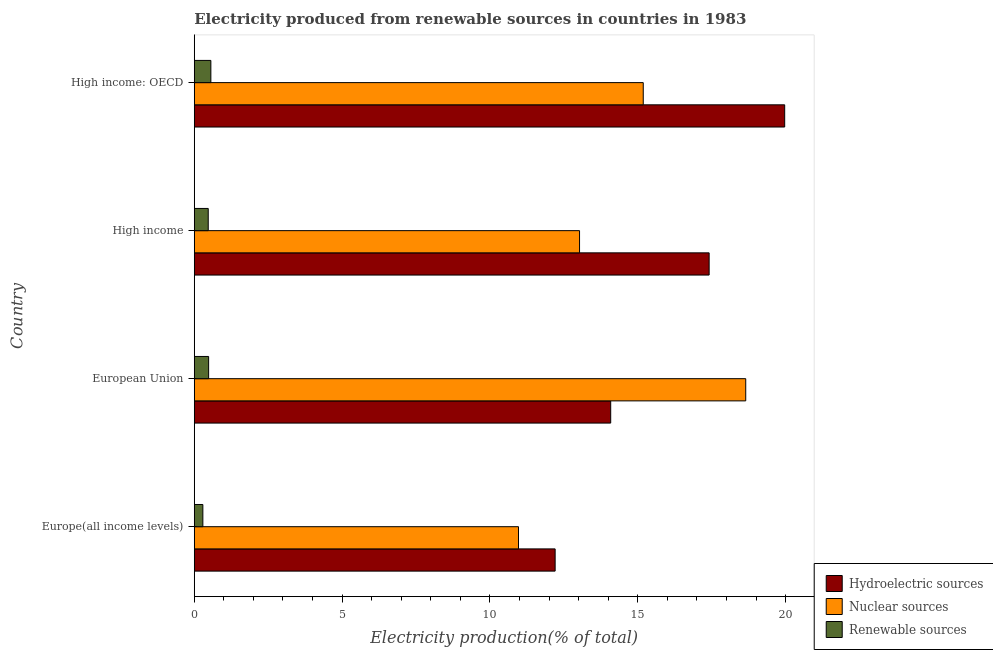How many groups of bars are there?
Ensure brevity in your answer.  4. Are the number of bars per tick equal to the number of legend labels?
Ensure brevity in your answer.  Yes. How many bars are there on the 3rd tick from the top?
Give a very brief answer. 3. What is the label of the 2nd group of bars from the top?
Your response must be concise. High income. In how many cases, is the number of bars for a given country not equal to the number of legend labels?
Offer a very short reply. 0. What is the percentage of electricity produced by renewable sources in High income?
Your answer should be very brief. 0.47. Across all countries, what is the maximum percentage of electricity produced by nuclear sources?
Offer a very short reply. 18.65. Across all countries, what is the minimum percentage of electricity produced by nuclear sources?
Provide a short and direct response. 10.97. In which country was the percentage of electricity produced by hydroelectric sources maximum?
Your response must be concise. High income: OECD. In which country was the percentage of electricity produced by renewable sources minimum?
Your response must be concise. Europe(all income levels). What is the total percentage of electricity produced by hydroelectric sources in the graph?
Offer a terse response. 63.68. What is the difference between the percentage of electricity produced by nuclear sources in High income and that in High income: OECD?
Your answer should be compact. -2.15. What is the difference between the percentage of electricity produced by nuclear sources in High income and the percentage of electricity produced by renewable sources in High income: OECD?
Give a very brief answer. 12.47. What is the average percentage of electricity produced by nuclear sources per country?
Your answer should be very brief. 14.46. What is the difference between the percentage of electricity produced by renewable sources and percentage of electricity produced by nuclear sources in High income?
Give a very brief answer. -12.56. In how many countries, is the percentage of electricity produced by nuclear sources greater than 9 %?
Give a very brief answer. 4. What is the ratio of the percentage of electricity produced by renewable sources in Europe(all income levels) to that in European Union?
Give a very brief answer. 0.6. Is the difference between the percentage of electricity produced by hydroelectric sources in European Union and High income greater than the difference between the percentage of electricity produced by nuclear sources in European Union and High income?
Your response must be concise. No. What is the difference between the highest and the second highest percentage of electricity produced by renewable sources?
Make the answer very short. 0.07. What is the difference between the highest and the lowest percentage of electricity produced by hydroelectric sources?
Provide a succinct answer. 7.76. Is the sum of the percentage of electricity produced by hydroelectric sources in Europe(all income levels) and European Union greater than the maximum percentage of electricity produced by nuclear sources across all countries?
Ensure brevity in your answer.  Yes. What does the 1st bar from the top in High income represents?
Your answer should be very brief. Renewable sources. What does the 3rd bar from the bottom in Europe(all income levels) represents?
Provide a short and direct response. Renewable sources. Is it the case that in every country, the sum of the percentage of electricity produced by hydroelectric sources and percentage of electricity produced by nuclear sources is greater than the percentage of electricity produced by renewable sources?
Make the answer very short. Yes. How many bars are there?
Your answer should be compact. 12. Are the values on the major ticks of X-axis written in scientific E-notation?
Offer a very short reply. No. Does the graph contain any zero values?
Provide a succinct answer. No. How many legend labels are there?
Provide a short and direct response. 3. What is the title of the graph?
Provide a succinct answer. Electricity produced from renewable sources in countries in 1983. Does "Grants" appear as one of the legend labels in the graph?
Give a very brief answer. No. What is the label or title of the Y-axis?
Ensure brevity in your answer.  Country. What is the Electricity production(% of total) in Hydroelectric sources in Europe(all income levels)?
Give a very brief answer. 12.21. What is the Electricity production(% of total) in Nuclear sources in Europe(all income levels)?
Provide a succinct answer. 10.97. What is the Electricity production(% of total) in Renewable sources in Europe(all income levels)?
Offer a very short reply. 0.29. What is the Electricity production(% of total) of Hydroelectric sources in European Union?
Your response must be concise. 14.09. What is the Electricity production(% of total) in Nuclear sources in European Union?
Ensure brevity in your answer.  18.65. What is the Electricity production(% of total) of Renewable sources in European Union?
Keep it short and to the point. 0.49. What is the Electricity production(% of total) in Hydroelectric sources in High income?
Your answer should be compact. 17.41. What is the Electricity production(% of total) of Nuclear sources in High income?
Ensure brevity in your answer.  13.03. What is the Electricity production(% of total) of Renewable sources in High income?
Provide a succinct answer. 0.47. What is the Electricity production(% of total) in Hydroelectric sources in High income: OECD?
Your answer should be compact. 19.97. What is the Electricity production(% of total) of Nuclear sources in High income: OECD?
Your answer should be compact. 15.19. What is the Electricity production(% of total) in Renewable sources in High income: OECD?
Ensure brevity in your answer.  0.56. Across all countries, what is the maximum Electricity production(% of total) of Hydroelectric sources?
Make the answer very short. 19.97. Across all countries, what is the maximum Electricity production(% of total) of Nuclear sources?
Make the answer very short. 18.65. Across all countries, what is the maximum Electricity production(% of total) in Renewable sources?
Your answer should be compact. 0.56. Across all countries, what is the minimum Electricity production(% of total) of Hydroelectric sources?
Your response must be concise. 12.21. Across all countries, what is the minimum Electricity production(% of total) of Nuclear sources?
Give a very brief answer. 10.97. Across all countries, what is the minimum Electricity production(% of total) in Renewable sources?
Your answer should be compact. 0.29. What is the total Electricity production(% of total) of Hydroelectric sources in the graph?
Offer a very short reply. 63.68. What is the total Electricity production(% of total) of Nuclear sources in the graph?
Ensure brevity in your answer.  57.84. What is the total Electricity production(% of total) in Renewable sources in the graph?
Offer a very short reply. 1.81. What is the difference between the Electricity production(% of total) in Hydroelectric sources in Europe(all income levels) and that in European Union?
Make the answer very short. -1.88. What is the difference between the Electricity production(% of total) in Nuclear sources in Europe(all income levels) and that in European Union?
Offer a very short reply. -7.69. What is the difference between the Electricity production(% of total) of Renewable sources in Europe(all income levels) and that in European Union?
Keep it short and to the point. -0.2. What is the difference between the Electricity production(% of total) of Hydroelectric sources in Europe(all income levels) and that in High income?
Make the answer very short. -5.21. What is the difference between the Electricity production(% of total) of Nuclear sources in Europe(all income levels) and that in High income?
Your response must be concise. -2.06. What is the difference between the Electricity production(% of total) in Renewable sources in Europe(all income levels) and that in High income?
Your response must be concise. -0.18. What is the difference between the Electricity production(% of total) in Hydroelectric sources in Europe(all income levels) and that in High income: OECD?
Your response must be concise. -7.76. What is the difference between the Electricity production(% of total) in Nuclear sources in Europe(all income levels) and that in High income: OECD?
Offer a terse response. -4.22. What is the difference between the Electricity production(% of total) in Renewable sources in Europe(all income levels) and that in High income: OECD?
Offer a very short reply. -0.27. What is the difference between the Electricity production(% of total) of Hydroelectric sources in European Union and that in High income?
Provide a succinct answer. -3.33. What is the difference between the Electricity production(% of total) in Nuclear sources in European Union and that in High income?
Provide a succinct answer. 5.62. What is the difference between the Electricity production(% of total) of Renewable sources in European Union and that in High income?
Provide a short and direct response. 0.01. What is the difference between the Electricity production(% of total) of Hydroelectric sources in European Union and that in High income: OECD?
Ensure brevity in your answer.  -5.88. What is the difference between the Electricity production(% of total) of Nuclear sources in European Union and that in High income: OECD?
Provide a short and direct response. 3.47. What is the difference between the Electricity production(% of total) of Renewable sources in European Union and that in High income: OECD?
Your answer should be compact. -0.08. What is the difference between the Electricity production(% of total) in Hydroelectric sources in High income and that in High income: OECD?
Provide a short and direct response. -2.56. What is the difference between the Electricity production(% of total) in Nuclear sources in High income and that in High income: OECD?
Provide a short and direct response. -2.15. What is the difference between the Electricity production(% of total) of Renewable sources in High income and that in High income: OECD?
Provide a succinct answer. -0.09. What is the difference between the Electricity production(% of total) of Hydroelectric sources in Europe(all income levels) and the Electricity production(% of total) of Nuclear sources in European Union?
Offer a terse response. -6.45. What is the difference between the Electricity production(% of total) of Hydroelectric sources in Europe(all income levels) and the Electricity production(% of total) of Renewable sources in European Union?
Ensure brevity in your answer.  11.72. What is the difference between the Electricity production(% of total) in Nuclear sources in Europe(all income levels) and the Electricity production(% of total) in Renewable sources in European Union?
Your answer should be compact. 10.48. What is the difference between the Electricity production(% of total) of Hydroelectric sources in Europe(all income levels) and the Electricity production(% of total) of Nuclear sources in High income?
Your response must be concise. -0.83. What is the difference between the Electricity production(% of total) of Hydroelectric sources in Europe(all income levels) and the Electricity production(% of total) of Renewable sources in High income?
Offer a very short reply. 11.73. What is the difference between the Electricity production(% of total) in Nuclear sources in Europe(all income levels) and the Electricity production(% of total) in Renewable sources in High income?
Make the answer very short. 10.49. What is the difference between the Electricity production(% of total) of Hydroelectric sources in Europe(all income levels) and the Electricity production(% of total) of Nuclear sources in High income: OECD?
Offer a very short reply. -2.98. What is the difference between the Electricity production(% of total) of Hydroelectric sources in Europe(all income levels) and the Electricity production(% of total) of Renewable sources in High income: OECD?
Offer a terse response. 11.64. What is the difference between the Electricity production(% of total) of Nuclear sources in Europe(all income levels) and the Electricity production(% of total) of Renewable sources in High income: OECD?
Offer a terse response. 10.41. What is the difference between the Electricity production(% of total) in Hydroelectric sources in European Union and the Electricity production(% of total) in Nuclear sources in High income?
Provide a succinct answer. 1.05. What is the difference between the Electricity production(% of total) of Hydroelectric sources in European Union and the Electricity production(% of total) of Renewable sources in High income?
Your answer should be compact. 13.61. What is the difference between the Electricity production(% of total) of Nuclear sources in European Union and the Electricity production(% of total) of Renewable sources in High income?
Your response must be concise. 18.18. What is the difference between the Electricity production(% of total) of Hydroelectric sources in European Union and the Electricity production(% of total) of Nuclear sources in High income: OECD?
Your answer should be very brief. -1.1. What is the difference between the Electricity production(% of total) in Hydroelectric sources in European Union and the Electricity production(% of total) in Renewable sources in High income: OECD?
Provide a succinct answer. 13.52. What is the difference between the Electricity production(% of total) in Nuclear sources in European Union and the Electricity production(% of total) in Renewable sources in High income: OECD?
Provide a succinct answer. 18.09. What is the difference between the Electricity production(% of total) in Hydroelectric sources in High income and the Electricity production(% of total) in Nuclear sources in High income: OECD?
Offer a very short reply. 2.23. What is the difference between the Electricity production(% of total) in Hydroelectric sources in High income and the Electricity production(% of total) in Renewable sources in High income: OECD?
Provide a succinct answer. 16.85. What is the difference between the Electricity production(% of total) in Nuclear sources in High income and the Electricity production(% of total) in Renewable sources in High income: OECD?
Give a very brief answer. 12.47. What is the average Electricity production(% of total) in Hydroelectric sources per country?
Offer a terse response. 15.92. What is the average Electricity production(% of total) of Nuclear sources per country?
Keep it short and to the point. 14.46. What is the average Electricity production(% of total) in Renewable sources per country?
Provide a short and direct response. 0.45. What is the difference between the Electricity production(% of total) in Hydroelectric sources and Electricity production(% of total) in Nuclear sources in Europe(all income levels)?
Give a very brief answer. 1.24. What is the difference between the Electricity production(% of total) of Hydroelectric sources and Electricity production(% of total) of Renewable sources in Europe(all income levels)?
Give a very brief answer. 11.92. What is the difference between the Electricity production(% of total) of Nuclear sources and Electricity production(% of total) of Renewable sources in Europe(all income levels)?
Make the answer very short. 10.68. What is the difference between the Electricity production(% of total) of Hydroelectric sources and Electricity production(% of total) of Nuclear sources in European Union?
Offer a terse response. -4.57. What is the difference between the Electricity production(% of total) of Hydroelectric sources and Electricity production(% of total) of Renewable sources in European Union?
Keep it short and to the point. 13.6. What is the difference between the Electricity production(% of total) in Nuclear sources and Electricity production(% of total) in Renewable sources in European Union?
Give a very brief answer. 18.17. What is the difference between the Electricity production(% of total) of Hydroelectric sources and Electricity production(% of total) of Nuclear sources in High income?
Ensure brevity in your answer.  4.38. What is the difference between the Electricity production(% of total) in Hydroelectric sources and Electricity production(% of total) in Renewable sources in High income?
Offer a terse response. 16.94. What is the difference between the Electricity production(% of total) of Nuclear sources and Electricity production(% of total) of Renewable sources in High income?
Give a very brief answer. 12.56. What is the difference between the Electricity production(% of total) in Hydroelectric sources and Electricity production(% of total) in Nuclear sources in High income: OECD?
Your answer should be compact. 4.78. What is the difference between the Electricity production(% of total) of Hydroelectric sources and Electricity production(% of total) of Renewable sources in High income: OECD?
Offer a terse response. 19.41. What is the difference between the Electricity production(% of total) in Nuclear sources and Electricity production(% of total) in Renewable sources in High income: OECD?
Offer a terse response. 14.62. What is the ratio of the Electricity production(% of total) in Hydroelectric sources in Europe(all income levels) to that in European Union?
Provide a succinct answer. 0.87. What is the ratio of the Electricity production(% of total) in Nuclear sources in Europe(all income levels) to that in European Union?
Your answer should be very brief. 0.59. What is the ratio of the Electricity production(% of total) of Renewable sources in Europe(all income levels) to that in European Union?
Your answer should be very brief. 0.6. What is the ratio of the Electricity production(% of total) of Hydroelectric sources in Europe(all income levels) to that in High income?
Offer a terse response. 0.7. What is the ratio of the Electricity production(% of total) in Nuclear sources in Europe(all income levels) to that in High income?
Your response must be concise. 0.84. What is the ratio of the Electricity production(% of total) of Renewable sources in Europe(all income levels) to that in High income?
Your response must be concise. 0.61. What is the ratio of the Electricity production(% of total) in Hydroelectric sources in Europe(all income levels) to that in High income: OECD?
Your answer should be compact. 0.61. What is the ratio of the Electricity production(% of total) in Nuclear sources in Europe(all income levels) to that in High income: OECD?
Ensure brevity in your answer.  0.72. What is the ratio of the Electricity production(% of total) of Renewable sources in Europe(all income levels) to that in High income: OECD?
Ensure brevity in your answer.  0.52. What is the ratio of the Electricity production(% of total) of Hydroelectric sources in European Union to that in High income?
Give a very brief answer. 0.81. What is the ratio of the Electricity production(% of total) of Nuclear sources in European Union to that in High income?
Keep it short and to the point. 1.43. What is the ratio of the Electricity production(% of total) in Renewable sources in European Union to that in High income?
Your response must be concise. 1.03. What is the ratio of the Electricity production(% of total) in Hydroelectric sources in European Union to that in High income: OECD?
Offer a terse response. 0.71. What is the ratio of the Electricity production(% of total) in Nuclear sources in European Union to that in High income: OECD?
Keep it short and to the point. 1.23. What is the ratio of the Electricity production(% of total) of Renewable sources in European Union to that in High income: OECD?
Make the answer very short. 0.87. What is the ratio of the Electricity production(% of total) in Hydroelectric sources in High income to that in High income: OECD?
Your response must be concise. 0.87. What is the ratio of the Electricity production(% of total) in Nuclear sources in High income to that in High income: OECD?
Ensure brevity in your answer.  0.86. What is the ratio of the Electricity production(% of total) in Renewable sources in High income to that in High income: OECD?
Offer a very short reply. 0.84. What is the difference between the highest and the second highest Electricity production(% of total) of Hydroelectric sources?
Keep it short and to the point. 2.56. What is the difference between the highest and the second highest Electricity production(% of total) in Nuclear sources?
Ensure brevity in your answer.  3.47. What is the difference between the highest and the second highest Electricity production(% of total) in Renewable sources?
Give a very brief answer. 0.08. What is the difference between the highest and the lowest Electricity production(% of total) in Hydroelectric sources?
Your answer should be very brief. 7.76. What is the difference between the highest and the lowest Electricity production(% of total) in Nuclear sources?
Provide a short and direct response. 7.69. What is the difference between the highest and the lowest Electricity production(% of total) of Renewable sources?
Make the answer very short. 0.27. 